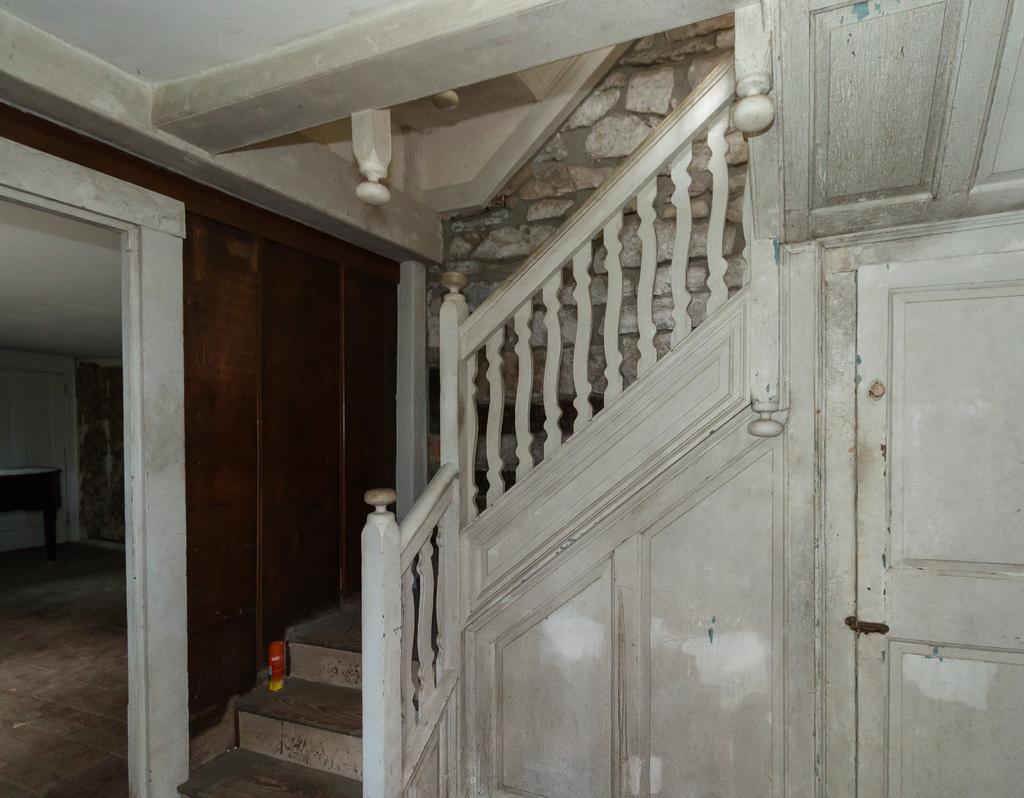Could you give a brief overview of what you see in this image? In this picture I can see the inside view of a house, there is a table, there are stairs, and in the background there is a wall. 